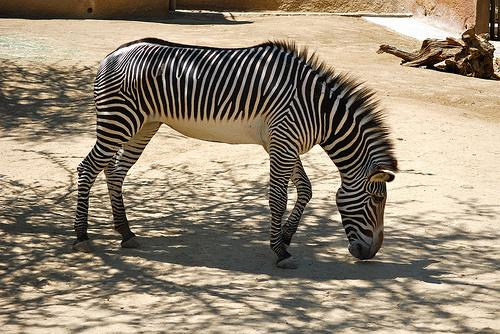Question: when was the picture taken?
Choices:
A. Night.
B. Dusk.
C. During the day.
D. Dawn.
Answer with the letter. Answer: C Question: what color are the zebra's stripes?
Choices:
A. Black and white.
B. Gray and white.
C. Blue and white.
D. Red and white.
Answer with the letter. Answer: A Question: who can be seen with the zebra?
Choices:
A. No one.
B. Someone.
C. Anyone.
D. A girl.
Answer with the letter. Answer: A Question: why was the picture taken?
Choices:
A. To capture the rainbow.
B. To capture the zebra.
C. To capture the tiger.
D. To capture the butterfly.
Answer with the letter. Answer: B Question: what is the zebra doing?
Choices:
A. Eating.
B. Searching.
C. Playing.
D. Sniffing for food.
Answer with the letter. Answer: D 